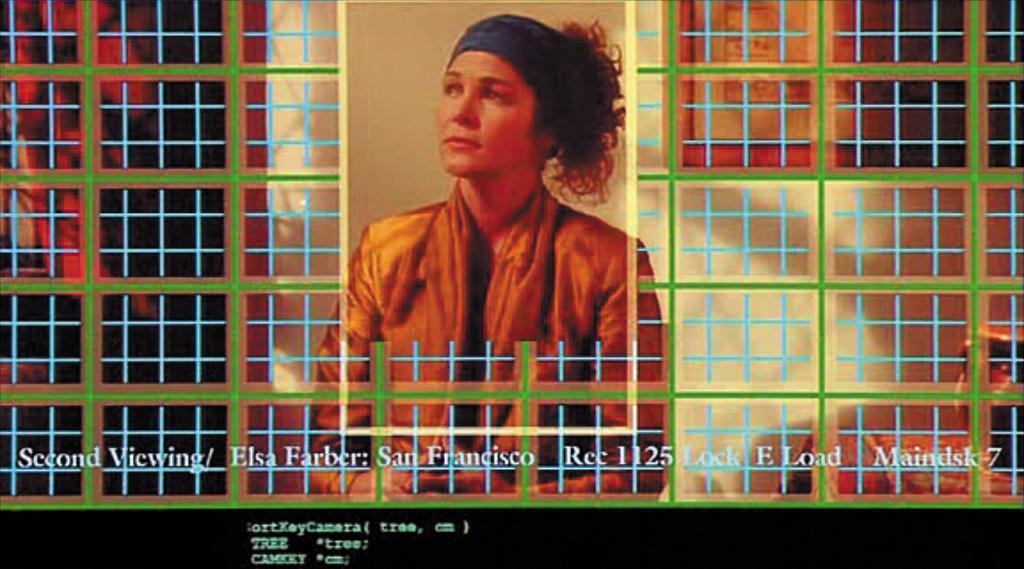Describe this image in one or two sentences. This is an edited image. We can see a woman. On the left and right side of the image, it looks like wire mesh. Behind the woman there is a wall. On the image, it is written something. 